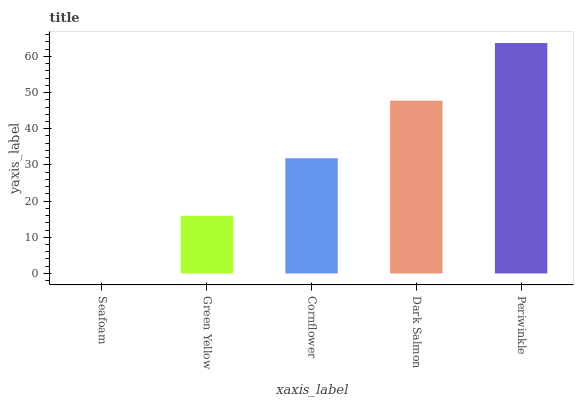Is Seafoam the minimum?
Answer yes or no. Yes. Is Periwinkle the maximum?
Answer yes or no. Yes. Is Green Yellow the minimum?
Answer yes or no. No. Is Green Yellow the maximum?
Answer yes or no. No. Is Green Yellow greater than Seafoam?
Answer yes or no. Yes. Is Seafoam less than Green Yellow?
Answer yes or no. Yes. Is Seafoam greater than Green Yellow?
Answer yes or no. No. Is Green Yellow less than Seafoam?
Answer yes or no. No. Is Cornflower the high median?
Answer yes or no. Yes. Is Cornflower the low median?
Answer yes or no. Yes. Is Periwinkle the high median?
Answer yes or no. No. Is Dark Salmon the low median?
Answer yes or no. No. 